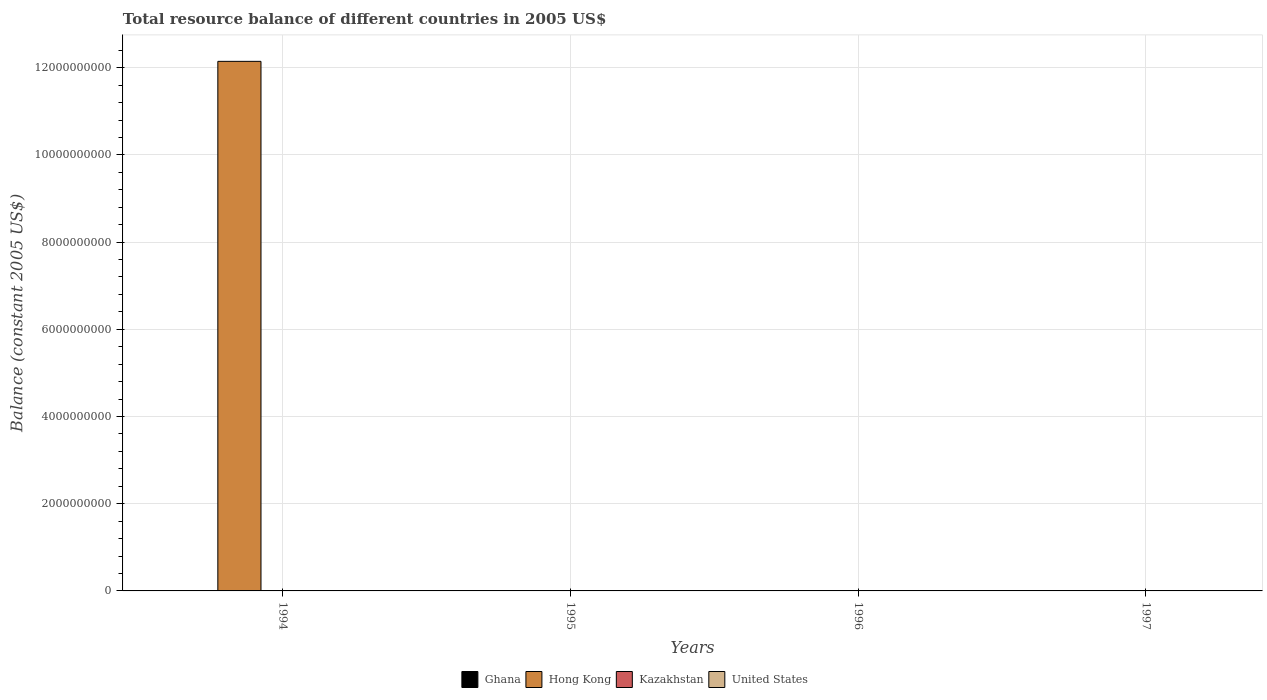How many different coloured bars are there?
Offer a very short reply. 1. How many bars are there on the 3rd tick from the left?
Provide a succinct answer. 0. How many bars are there on the 4th tick from the right?
Your response must be concise. 1. In how many cases, is the number of bars for a given year not equal to the number of legend labels?
Your response must be concise. 4. What is the total resource balance in Kazakhstan in 1995?
Your answer should be very brief. 0. Across all years, what is the maximum total resource balance in Hong Kong?
Your response must be concise. 1.21e+1. Across all years, what is the minimum total resource balance in Hong Kong?
Your answer should be very brief. 0. In which year was the total resource balance in Hong Kong maximum?
Provide a short and direct response. 1994. What is the total total resource balance in Ghana in the graph?
Your answer should be compact. 0. What is the average total resource balance in United States per year?
Provide a succinct answer. 0. In how many years, is the total resource balance in United States greater than 400000000 US$?
Offer a terse response. 0. What is the difference between the highest and the lowest total resource balance in Hong Kong?
Offer a very short reply. 1.21e+1. In how many years, is the total resource balance in Kazakhstan greater than the average total resource balance in Kazakhstan taken over all years?
Your response must be concise. 0. Is it the case that in every year, the sum of the total resource balance in Hong Kong and total resource balance in Ghana is greater than the sum of total resource balance in United States and total resource balance in Kazakhstan?
Provide a short and direct response. No. How many bars are there?
Your response must be concise. 1. How many years are there in the graph?
Give a very brief answer. 4. Are the values on the major ticks of Y-axis written in scientific E-notation?
Provide a short and direct response. No. Does the graph contain grids?
Offer a terse response. Yes. Where does the legend appear in the graph?
Give a very brief answer. Bottom center. How many legend labels are there?
Your answer should be very brief. 4. How are the legend labels stacked?
Your answer should be compact. Horizontal. What is the title of the graph?
Your answer should be compact. Total resource balance of different countries in 2005 US$. Does "Guinea-Bissau" appear as one of the legend labels in the graph?
Offer a very short reply. No. What is the label or title of the X-axis?
Your response must be concise. Years. What is the label or title of the Y-axis?
Your answer should be compact. Balance (constant 2005 US$). What is the Balance (constant 2005 US$) in Hong Kong in 1994?
Keep it short and to the point. 1.21e+1. What is the Balance (constant 2005 US$) in Kazakhstan in 1994?
Your answer should be compact. 0. What is the Balance (constant 2005 US$) of United States in 1994?
Provide a succinct answer. 0. What is the Balance (constant 2005 US$) in Hong Kong in 1995?
Your answer should be compact. 0. What is the Balance (constant 2005 US$) of Kazakhstan in 1995?
Give a very brief answer. 0. What is the Balance (constant 2005 US$) in Ghana in 1996?
Provide a short and direct response. 0. What is the Balance (constant 2005 US$) in Hong Kong in 1996?
Ensure brevity in your answer.  0. What is the Balance (constant 2005 US$) in Kazakhstan in 1996?
Ensure brevity in your answer.  0. What is the Balance (constant 2005 US$) of Ghana in 1997?
Ensure brevity in your answer.  0. What is the Balance (constant 2005 US$) of Hong Kong in 1997?
Your answer should be compact. 0. Across all years, what is the maximum Balance (constant 2005 US$) in Hong Kong?
Your response must be concise. 1.21e+1. What is the total Balance (constant 2005 US$) of Hong Kong in the graph?
Provide a short and direct response. 1.21e+1. What is the average Balance (constant 2005 US$) in Ghana per year?
Offer a very short reply. 0. What is the average Balance (constant 2005 US$) in Hong Kong per year?
Your answer should be very brief. 3.04e+09. What is the average Balance (constant 2005 US$) in United States per year?
Offer a terse response. 0. What is the difference between the highest and the lowest Balance (constant 2005 US$) in Hong Kong?
Your answer should be very brief. 1.21e+1. 